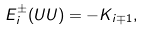Convert formula to latex. <formula><loc_0><loc_0><loc_500><loc_500>E _ { i } ^ { \pm } ( U U ) = - K _ { i \mp 1 } ,</formula> 